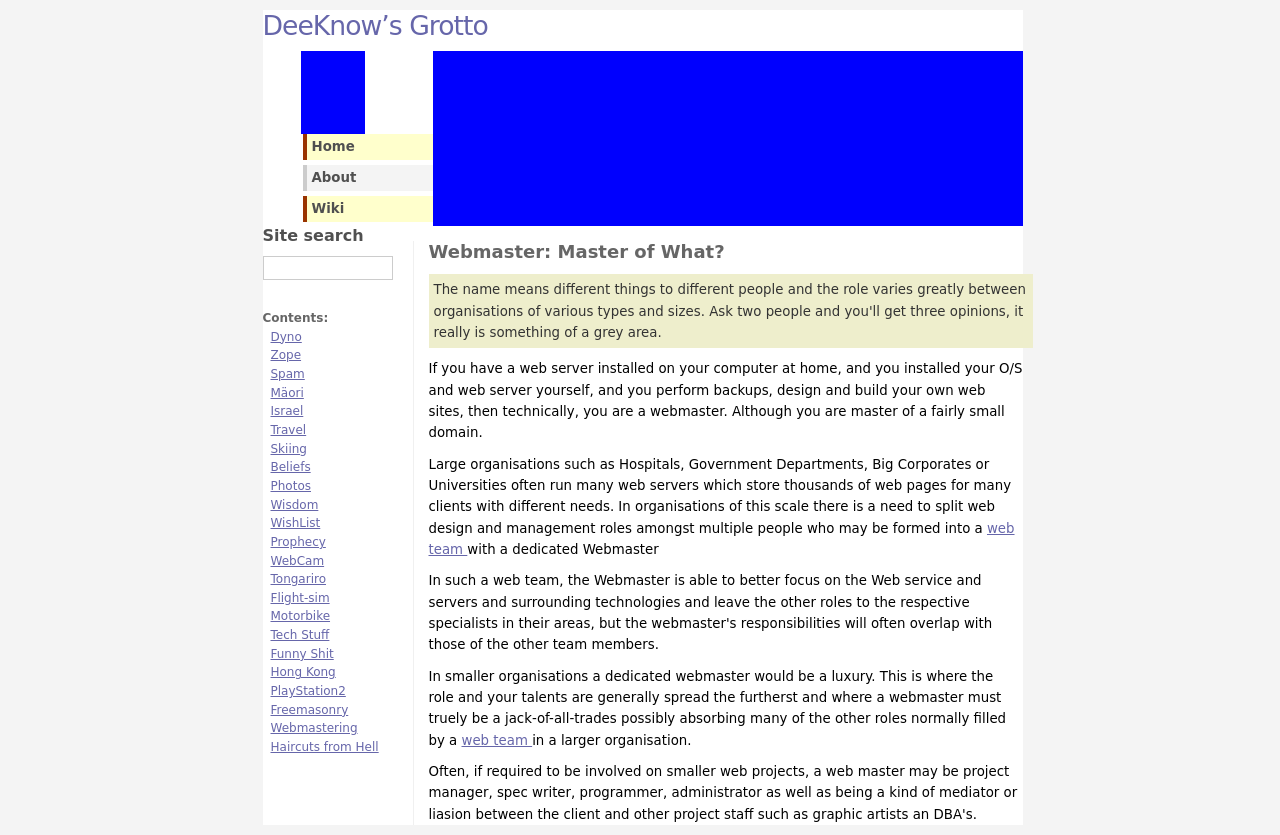Could you guide me through the process of developing this website with HTML? To begin developing a website similar to the one depicted in the image, start with a basic HTML structure. First, create a file named 'index.html' and open it in a text editor. Place the basic HTML structure:

<!DOCTYPE html>
<html>
<head>
    <title>Your Website's Title Here</title>
    <meta charset="UTF-8">
    <meta name="viewport" content="width=device-width, initial-scale=1.0">
    <link rel="stylesheet" type="text/css" href="style.css">
</head>
<body>
    <header>
        <h1>My Website</h1>
    </header>
    <nav>
        <ul>
            <li><a href="#home">Home</a></li>
            <li><a href="#about">About</a></li>
            <li><a href="#contact">Contact</a></li>
        </ul>
    </nav>
    <section id="content">
        <article>
            <h2>Welcome to My Website</h2>
            <p>This is paragraph text to explain the content of the site or the page.</p>
        </article>
    </section>
    <footer>
        <p>Copyright © 2023 Your Website Name</p>
    </footer>
</body>
</html>

Next, save and open this file in a web browser to see your basic site structure. Now, create a CSS file named 'style.css' to style your site. In 'style.css', you can define the visual appearance of your elements. 